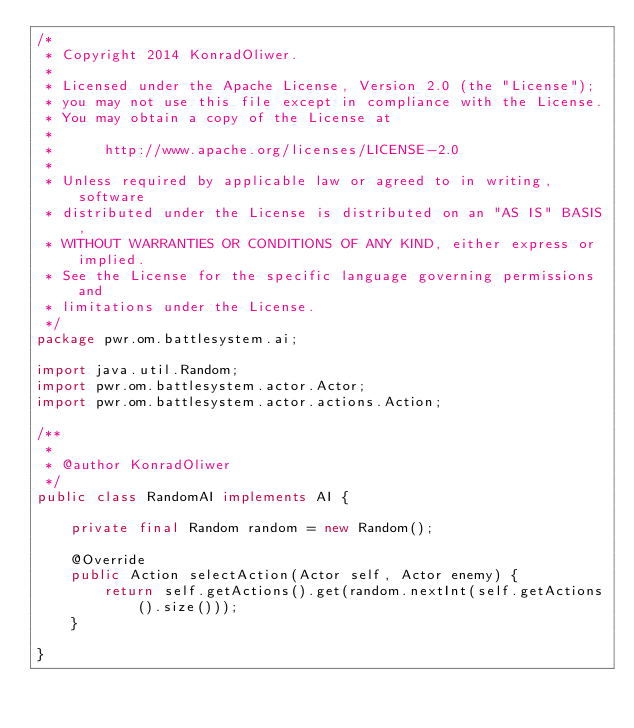Convert code to text. <code><loc_0><loc_0><loc_500><loc_500><_Java_>/*
 * Copyright 2014 KonradOliwer.
 *
 * Licensed under the Apache License, Version 2.0 (the "License");
 * you may not use this file except in compliance with the License.
 * You may obtain a copy of the License at
 *
 *      http://www.apache.org/licenses/LICENSE-2.0
 *
 * Unless required by applicable law or agreed to in writing, software
 * distributed under the License is distributed on an "AS IS" BASIS,
 * WITHOUT WARRANTIES OR CONDITIONS OF ANY KIND, either express or implied.
 * See the License for the specific language governing permissions and
 * limitations under the License.
 */
package pwr.om.battlesystem.ai;

import java.util.Random;
import pwr.om.battlesystem.actor.Actor;
import pwr.om.battlesystem.actor.actions.Action;

/**
 *
 * @author KonradOliwer
 */
public class RandomAI implements AI {

    private final Random random = new Random();

    @Override
    public Action selectAction(Actor self, Actor enemy) {
        return self.getActions().get(random.nextInt(self.getActions().size()));
    }

}
</code> 